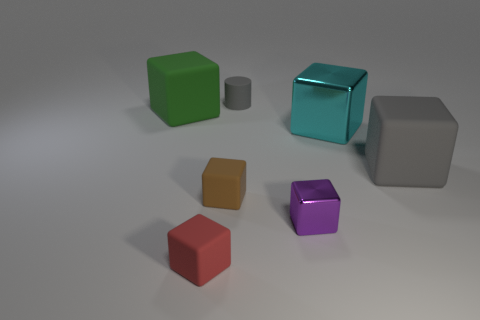Is there any other thing of the same color as the matte cylinder?
Provide a short and direct response. Yes. How big is the gray thing in front of the green block behind the cyan shiny block?
Give a very brief answer. Large. What is the color of the rubber cube that is behind the tiny brown rubber cube and in front of the green rubber cube?
Offer a very short reply. Gray. What number of other objects are the same size as the green rubber thing?
Make the answer very short. 2. There is a red rubber object; is it the same size as the matte cube that is to the right of the cyan metal block?
Offer a terse response. No. There is a metal block that is the same size as the brown rubber object; what is its color?
Your answer should be compact. Purple. What is the size of the brown thing?
Your response must be concise. Small. Is the material of the gray object on the left side of the large gray block the same as the purple block?
Provide a short and direct response. No. Do the tiny red rubber object and the big green rubber object have the same shape?
Keep it short and to the point. Yes. There is a gray object that is behind the rubber cube on the right side of the gray matte object that is left of the purple metallic cube; what is its shape?
Keep it short and to the point. Cylinder. 